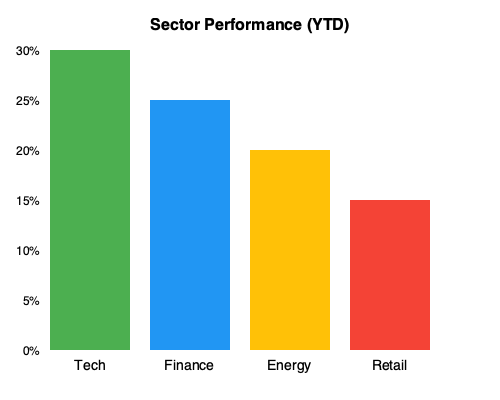Based on the bar graph showing Year-to-Date (YTD) sector performance, calculate the difference in percentage points between the best and worst performing sectors. Which sectors are these, and what strategy would you recommend to capitalize on this performance gap? To solve this problem, we need to follow these steps:

1. Identify the best and worst performing sectors:
   - Tech (leftmost bar): 30%
   - Finance: 25%
   - Energy: 20%
   - Retail (rightmost bar): 15%

   The best performing sector is Tech at 30%, and the worst is Retail at 15%.

2. Calculate the difference in percentage points:
   $30\% - 15\% = 15\%$ percentage points

3. Strategy recommendation:
   Given the significant performance gap, a potential strategy would be to implement a sector rotation approach. This involves:
   
   a) Overweighting the outperforming Tech sector in the portfolio.
   b) Underweighting or potentially shorting the underperforming Retail sector.
   c) Continuously monitoring sector trends for any potential reversals.
   d) Considering the factors driving the performance gap (e.g., technological advancements, changing consumer behaviors) for long-term investment decisions.

   It's important to note that past performance doesn't guarantee future results, so this strategy should be combined with thorough fundamental and technical analysis of individual stocks within these sectors.
Answer: 15 percentage points; Tech (best) and Retail (worst); Implement sector rotation strategy overweighting Tech and underweighting Retail. 